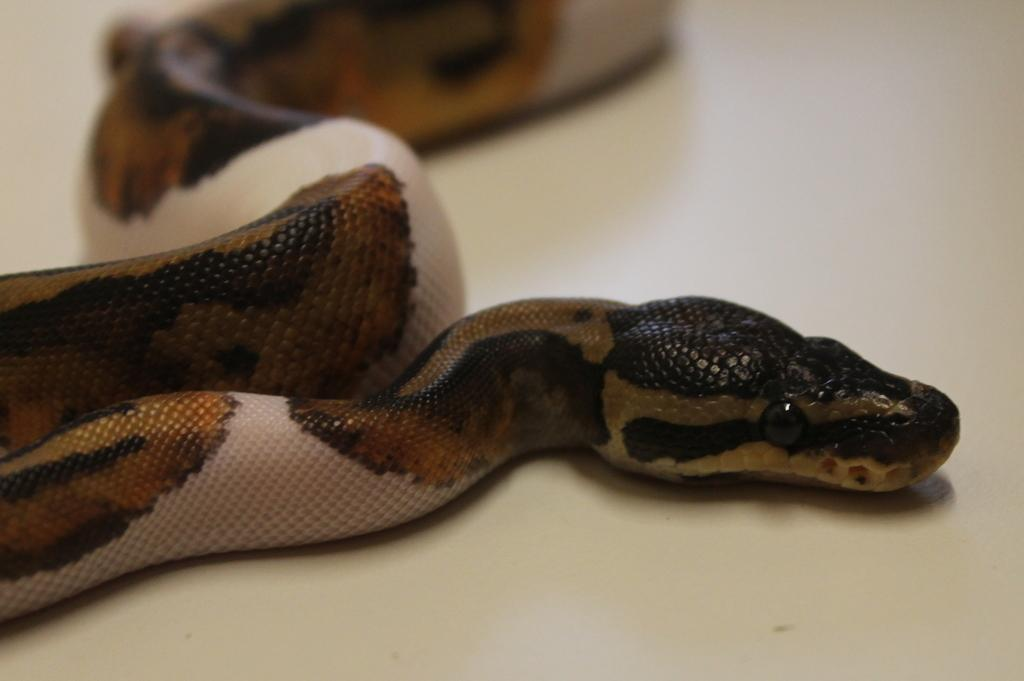What type of animal is in the image? There is a snake in the image. What colors can be seen on the snake? The snake has brown and cream colors. What is the snake resting on or interacting with in the image? The snake is on some object. Can you see any wrens perched on the roof in the image? There are no wrens or roofs present in the image; it features a snake with brown and cream colors resting on an unspecified object. 